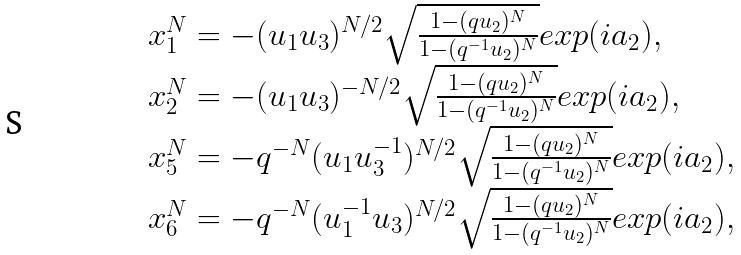<formula> <loc_0><loc_0><loc_500><loc_500>\begin{array} { l } { { x _ { 1 } ^ { N } = - ( u _ { 1 } u _ { 3 } ) ^ { N / 2 } \sqrt { \frac { 1 - ( q u _ { 2 } ) ^ { N } } { 1 - ( q ^ { - 1 } u _ { 2 } ) ^ { N } } } e x p ( i a _ { 2 } ) , } } \\ { { x _ { 2 } ^ { N } = - ( u _ { 1 } u _ { 3 } ) ^ { - N / 2 } \sqrt { \frac { 1 - ( q u _ { 2 } ) ^ { N } } { 1 - ( q ^ { - 1 } u _ { 2 } ) ^ { N } } } e x p ( i a _ { 2 } ) , } } \\ { { x _ { 5 } ^ { N } = - q ^ { - N } ( u _ { 1 } u _ { 3 } ^ { - 1 } ) ^ { N / 2 } \sqrt { \frac { 1 - ( q u _ { 2 } ) ^ { N } } { 1 - ( q ^ { - 1 } u _ { 2 } ) ^ { N } } } e x p ( i a _ { 2 } ) , } } \\ { { x _ { 6 } ^ { N } = - q ^ { - N } ( u _ { 1 } ^ { - 1 } u _ { 3 } ) ^ { N / 2 } \sqrt { \frac { 1 - ( q u _ { 2 } ) ^ { N } } { 1 - ( q ^ { - 1 } u _ { 2 } ) ^ { N } } } e x p ( i a _ { 2 } ) , } } \end{array}</formula> 